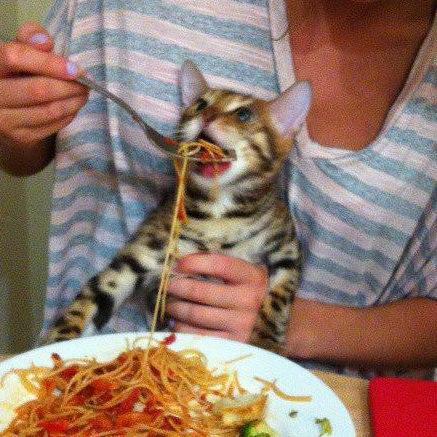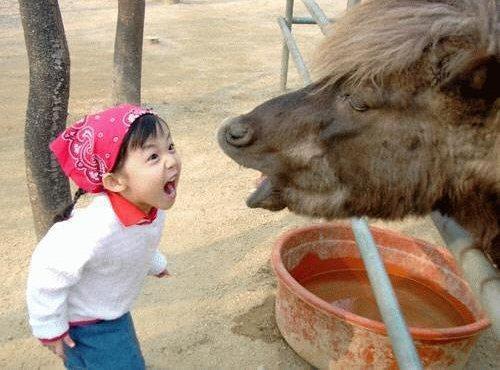The first image is the image on the left, the second image is the image on the right. For the images displayed, is the sentence "Someone is holding all the animals in the images." factually correct? Answer yes or no. No. 